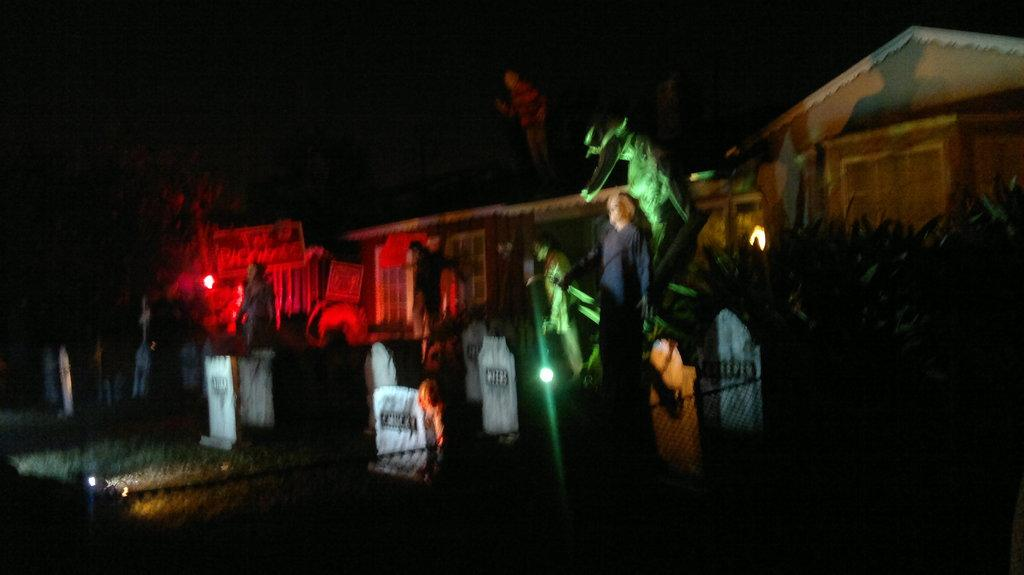What type of location is depicted in the image? There is a graveyard in the image. What kind of objects can be seen in the graveyard? There are statues in the image. What is visible in the background of the image? There is a wall in the background of the image. What type of powder is being used by the sister in the image? There is no sister or powder present in the image; it features a graveyard with statues and a wall in the background. 